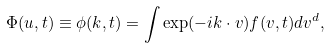<formula> <loc_0><loc_0><loc_500><loc_500>\Phi ( u , t ) \equiv \phi ( k , t ) = \int \exp ( - i { k } \cdot { v } ) f ( v , t ) d v ^ { d } ,</formula> 